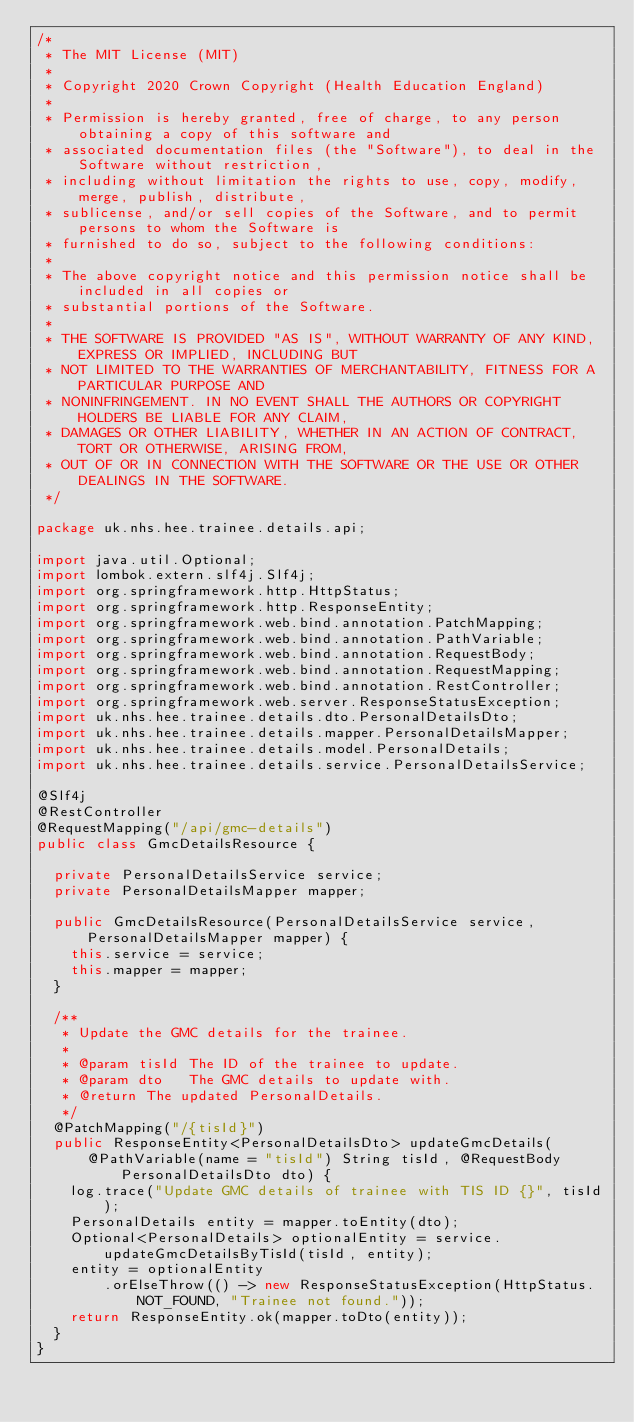<code> <loc_0><loc_0><loc_500><loc_500><_Java_>/*
 * The MIT License (MIT)
 *
 * Copyright 2020 Crown Copyright (Health Education England)
 *
 * Permission is hereby granted, free of charge, to any person obtaining a copy of this software and
 * associated documentation files (the "Software"), to deal in the Software without restriction,
 * including without limitation the rights to use, copy, modify, merge, publish, distribute,
 * sublicense, and/or sell copies of the Software, and to permit persons to whom the Software is
 * furnished to do so, subject to the following conditions:
 *
 * The above copyright notice and this permission notice shall be included in all copies or
 * substantial portions of the Software.
 *
 * THE SOFTWARE IS PROVIDED "AS IS", WITHOUT WARRANTY OF ANY KIND, EXPRESS OR IMPLIED, INCLUDING BUT
 * NOT LIMITED TO THE WARRANTIES OF MERCHANTABILITY, FITNESS FOR A PARTICULAR PURPOSE AND
 * NONINFRINGEMENT. IN NO EVENT SHALL THE AUTHORS OR COPYRIGHT HOLDERS BE LIABLE FOR ANY CLAIM,
 * DAMAGES OR OTHER LIABILITY, WHETHER IN AN ACTION OF CONTRACT, TORT OR OTHERWISE, ARISING FROM,
 * OUT OF OR IN CONNECTION WITH THE SOFTWARE OR THE USE OR OTHER DEALINGS IN THE SOFTWARE.
 */

package uk.nhs.hee.trainee.details.api;

import java.util.Optional;
import lombok.extern.slf4j.Slf4j;
import org.springframework.http.HttpStatus;
import org.springframework.http.ResponseEntity;
import org.springframework.web.bind.annotation.PatchMapping;
import org.springframework.web.bind.annotation.PathVariable;
import org.springframework.web.bind.annotation.RequestBody;
import org.springframework.web.bind.annotation.RequestMapping;
import org.springframework.web.bind.annotation.RestController;
import org.springframework.web.server.ResponseStatusException;
import uk.nhs.hee.trainee.details.dto.PersonalDetailsDto;
import uk.nhs.hee.trainee.details.mapper.PersonalDetailsMapper;
import uk.nhs.hee.trainee.details.model.PersonalDetails;
import uk.nhs.hee.trainee.details.service.PersonalDetailsService;

@Slf4j
@RestController
@RequestMapping("/api/gmc-details")
public class GmcDetailsResource {

  private PersonalDetailsService service;
  private PersonalDetailsMapper mapper;

  public GmcDetailsResource(PersonalDetailsService service, PersonalDetailsMapper mapper) {
    this.service = service;
    this.mapper = mapper;
  }

  /**
   * Update the GMC details for the trainee.
   *
   * @param tisId The ID of the trainee to update.
   * @param dto   The GMC details to update with.
   * @return The updated PersonalDetails.
   */
  @PatchMapping("/{tisId}")
  public ResponseEntity<PersonalDetailsDto> updateGmcDetails(
      @PathVariable(name = "tisId") String tisId, @RequestBody PersonalDetailsDto dto) {
    log.trace("Update GMC details of trainee with TIS ID {}", tisId);
    PersonalDetails entity = mapper.toEntity(dto);
    Optional<PersonalDetails> optionalEntity = service.updateGmcDetailsByTisId(tisId, entity);
    entity = optionalEntity
        .orElseThrow(() -> new ResponseStatusException(HttpStatus.NOT_FOUND, "Trainee not found."));
    return ResponseEntity.ok(mapper.toDto(entity));
  }
}
</code> 